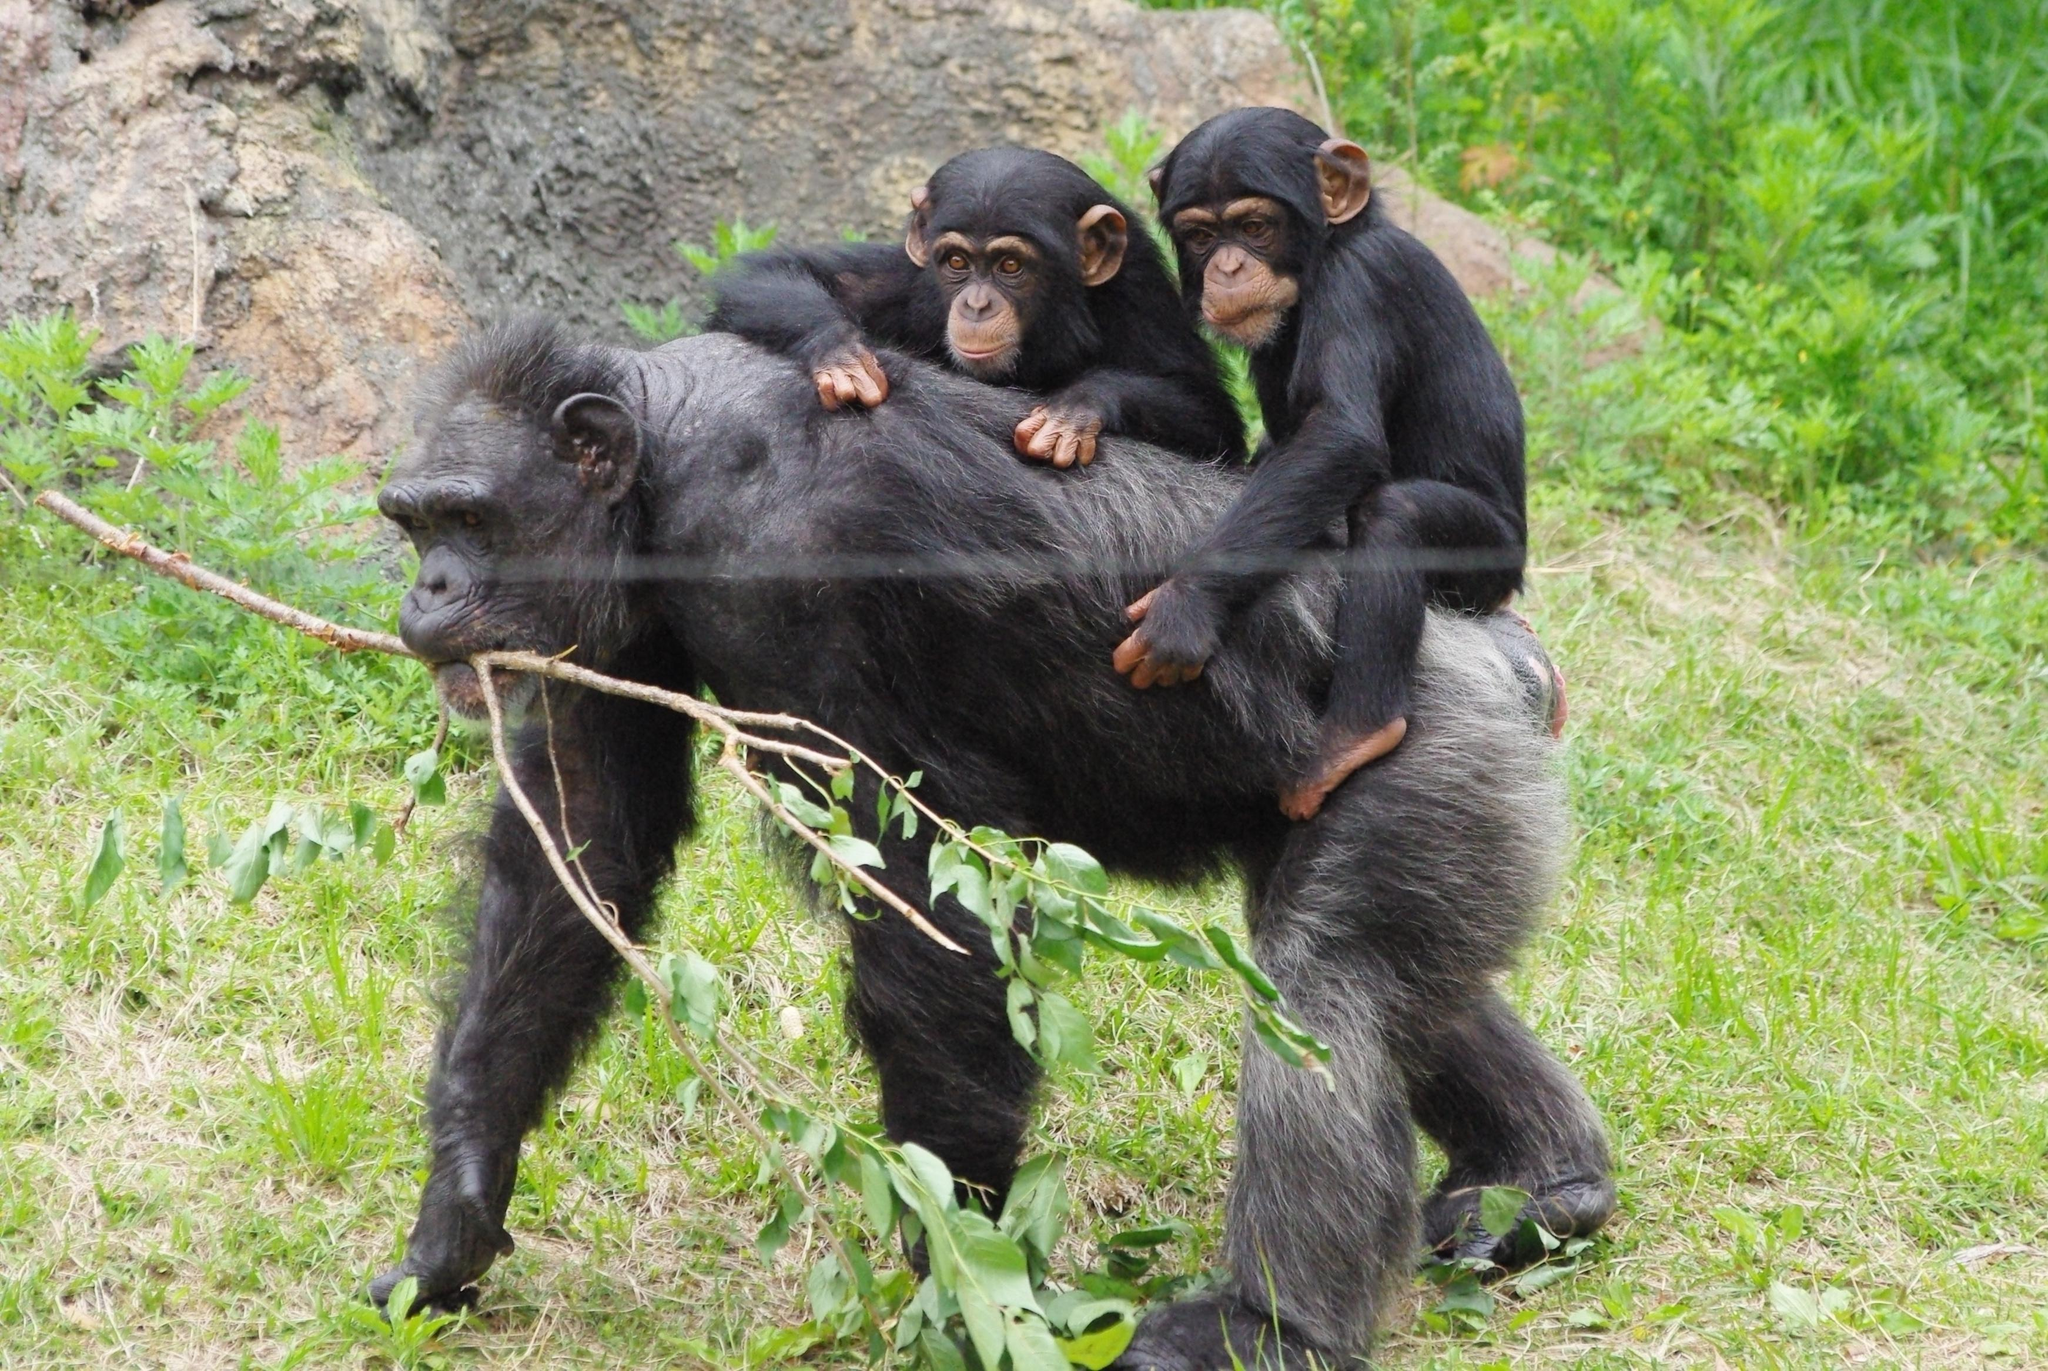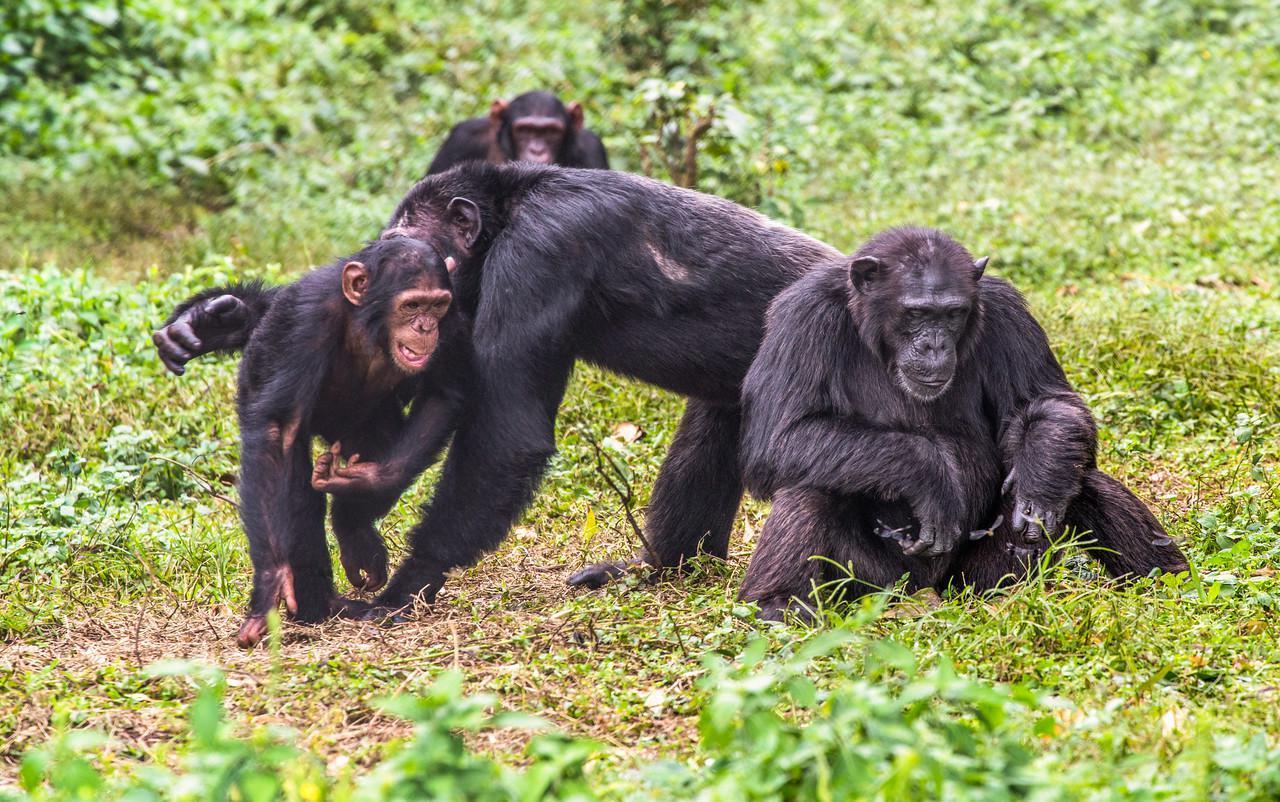The first image is the image on the left, the second image is the image on the right. Considering the images on both sides, is "An image shows just one baby chimp riding on its mother's back." valid? Answer yes or no. No. 